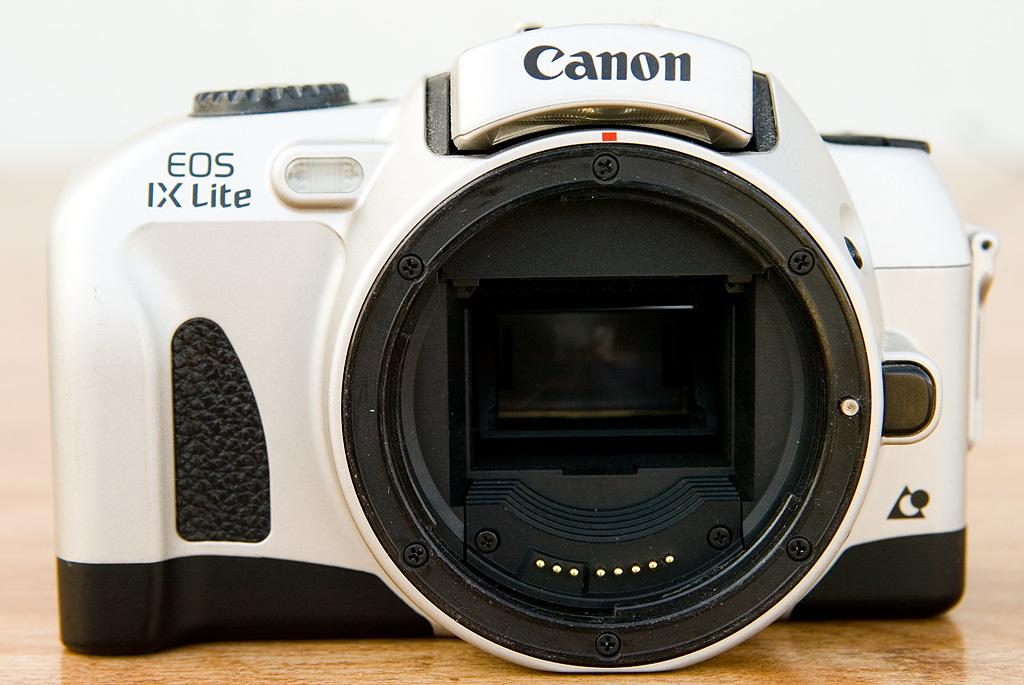What is the name of this canon camera?
Offer a very short reply. Eos ix lite. What brand is this camera?
Make the answer very short. Canon. 